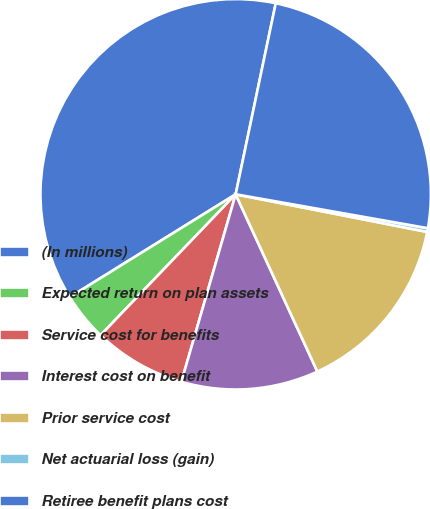Convert chart to OTSL. <chart><loc_0><loc_0><loc_500><loc_500><pie_chart><fcel>(In millions)<fcel>Expected return on plan assets<fcel>Service cost for benefits<fcel>Interest cost on benefit<fcel>Prior service cost<fcel>Net actuarial loss (gain)<fcel>Retiree benefit plans cost<nl><fcel>37.13%<fcel>4.0%<fcel>7.68%<fcel>11.36%<fcel>15.04%<fcel>0.31%<fcel>24.49%<nl></chart> 